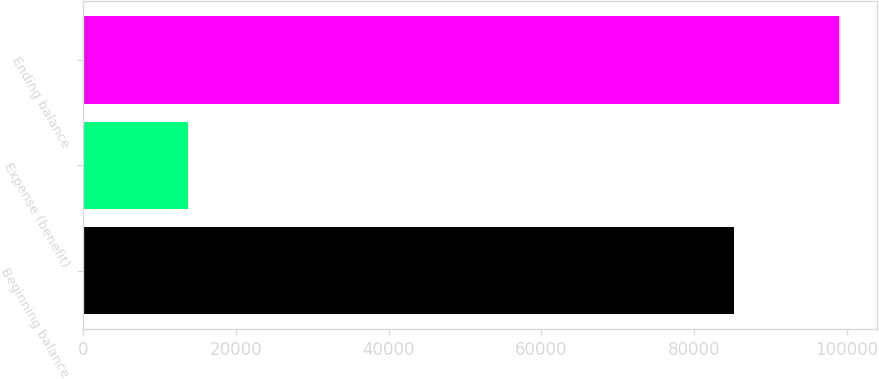Convert chart. <chart><loc_0><loc_0><loc_500><loc_500><bar_chart><fcel>Beginning balance<fcel>Expense (benefit)<fcel>Ending balance<nl><fcel>85207<fcel>13759<fcel>98966<nl></chart> 